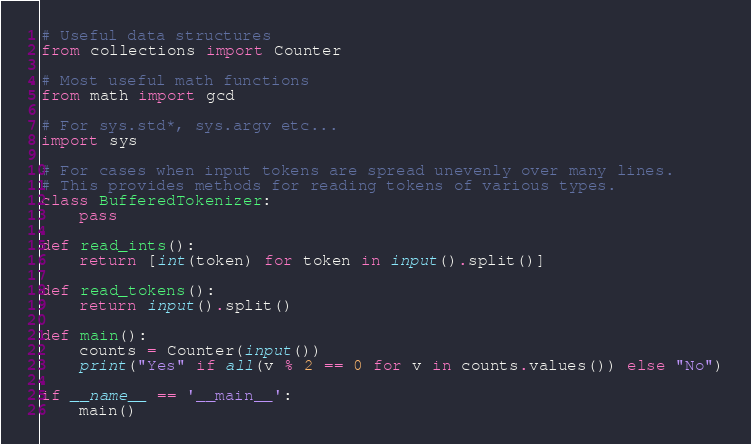Convert code to text. <code><loc_0><loc_0><loc_500><loc_500><_Python_># Useful data structures
from collections import Counter

# Most useful math functions
from math import gcd

# For sys.std*, sys.argv etc...
import sys

# For cases when input tokens are spread unevenly over many lines.
# This provides methods for reading tokens of various types.
class BufferedTokenizer:
    pass

def read_ints():
    return [int(token) for token in input().split()]

def read_tokens():
    return input().split()

def main():
    counts = Counter(input())
    print("Yes" if all(v % 2 == 0 for v in counts.values()) else "No")

if __name__ == '__main__':
    main()
</code> 